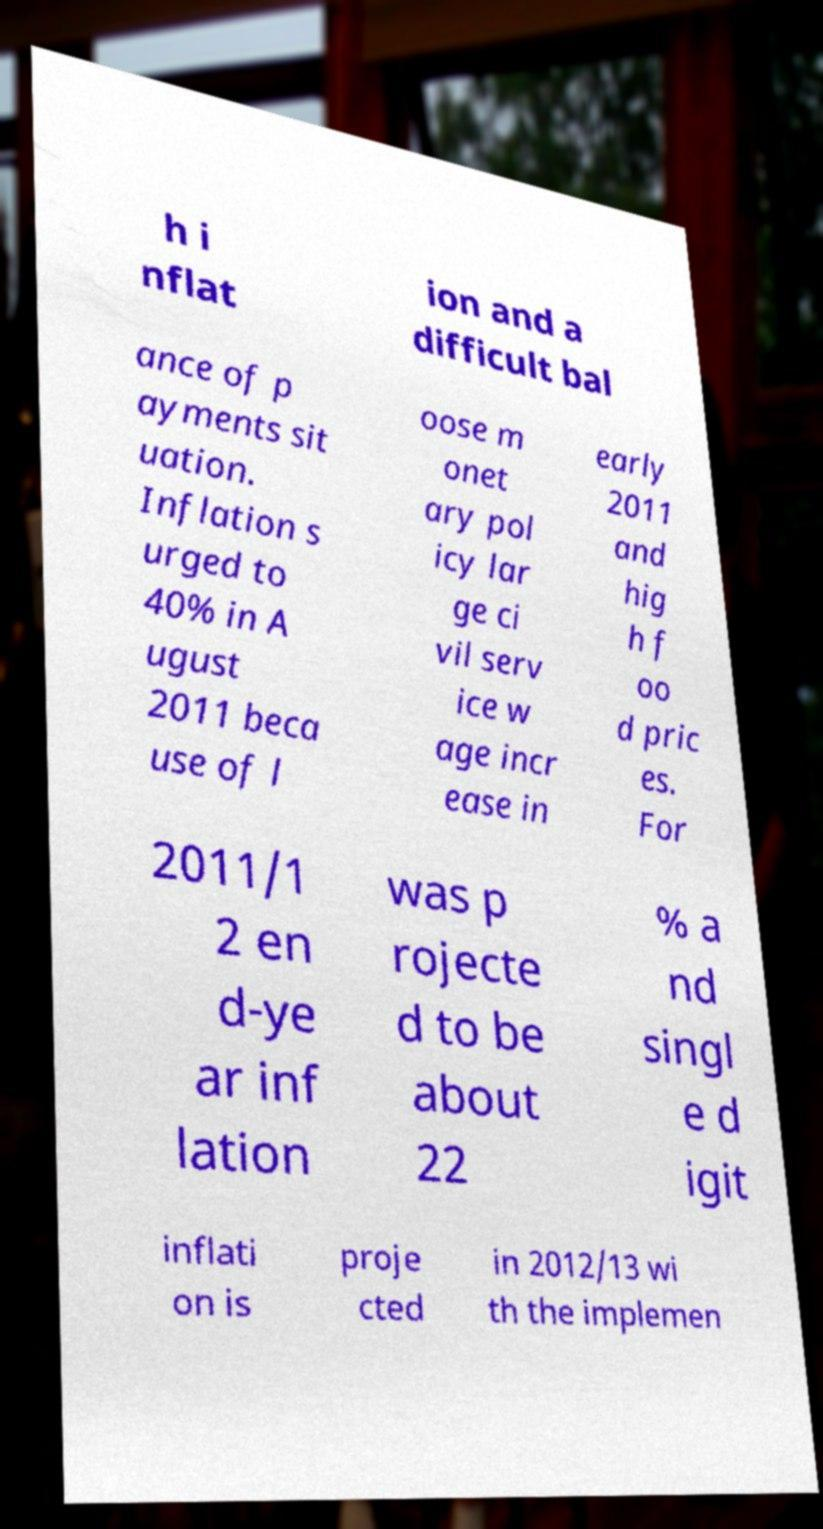Please identify and transcribe the text found in this image. h i nflat ion and a difficult bal ance of p ayments sit uation. Inflation s urged to 40% in A ugust 2011 beca use of l oose m onet ary pol icy lar ge ci vil serv ice w age incr ease in early 2011 and hig h f oo d pric es. For 2011/1 2 en d-ye ar inf lation was p rojecte d to be about 22 % a nd singl e d igit inflati on is proje cted in 2012/13 wi th the implemen 